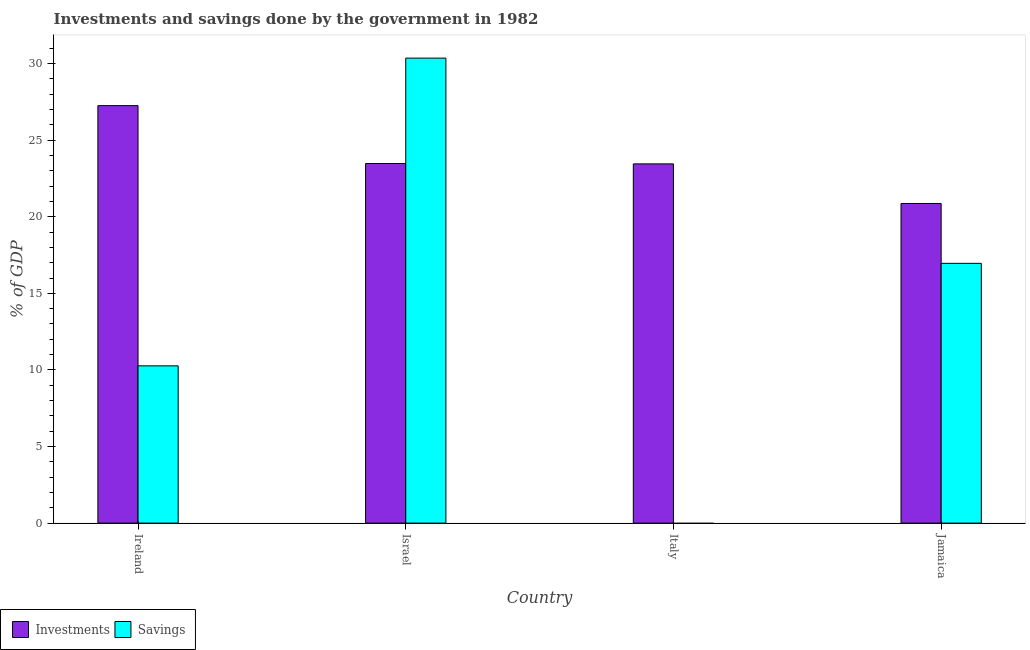How many different coloured bars are there?
Your answer should be very brief. 2. Are the number of bars on each tick of the X-axis equal?
Provide a short and direct response. No. What is the label of the 3rd group of bars from the left?
Ensure brevity in your answer.  Italy. In how many cases, is the number of bars for a given country not equal to the number of legend labels?
Provide a short and direct response. 1. What is the savings of government in Ireland?
Make the answer very short. 10.27. Across all countries, what is the maximum investments of government?
Provide a short and direct response. 27.26. Across all countries, what is the minimum savings of government?
Give a very brief answer. 0. In which country was the savings of government maximum?
Provide a succinct answer. Israel. What is the total investments of government in the graph?
Ensure brevity in your answer.  95.06. What is the difference between the investments of government in Israel and that in Jamaica?
Keep it short and to the point. 2.61. What is the difference between the investments of government in Israel and the savings of government in Ireland?
Make the answer very short. 13.21. What is the average investments of government per country?
Ensure brevity in your answer.  23.76. What is the difference between the investments of government and savings of government in Jamaica?
Ensure brevity in your answer.  3.91. What is the ratio of the investments of government in Ireland to that in Jamaica?
Your answer should be compact. 1.31. Is the savings of government in Ireland less than that in Jamaica?
Ensure brevity in your answer.  Yes. Is the difference between the investments of government in Ireland and Israel greater than the difference between the savings of government in Ireland and Israel?
Your answer should be very brief. Yes. What is the difference between the highest and the second highest investments of government?
Provide a short and direct response. 3.78. What is the difference between the highest and the lowest investments of government?
Keep it short and to the point. 6.39. How many countries are there in the graph?
Your answer should be very brief. 4. What is the difference between two consecutive major ticks on the Y-axis?
Ensure brevity in your answer.  5. Are the values on the major ticks of Y-axis written in scientific E-notation?
Keep it short and to the point. No. Does the graph contain grids?
Offer a very short reply. No. Where does the legend appear in the graph?
Provide a short and direct response. Bottom left. How many legend labels are there?
Provide a succinct answer. 2. What is the title of the graph?
Your answer should be very brief. Investments and savings done by the government in 1982. Does "Unregistered firms" appear as one of the legend labels in the graph?
Offer a very short reply. No. What is the label or title of the Y-axis?
Ensure brevity in your answer.  % of GDP. What is the % of GDP in Investments in Ireland?
Keep it short and to the point. 27.26. What is the % of GDP in Savings in Ireland?
Offer a terse response. 10.27. What is the % of GDP of Investments in Israel?
Your response must be concise. 23.48. What is the % of GDP in Savings in Israel?
Ensure brevity in your answer.  30.36. What is the % of GDP of Investments in Italy?
Your response must be concise. 23.45. What is the % of GDP in Investments in Jamaica?
Keep it short and to the point. 20.87. What is the % of GDP in Savings in Jamaica?
Provide a succinct answer. 16.96. Across all countries, what is the maximum % of GDP in Investments?
Offer a very short reply. 27.26. Across all countries, what is the maximum % of GDP of Savings?
Make the answer very short. 30.36. Across all countries, what is the minimum % of GDP in Investments?
Make the answer very short. 20.87. Across all countries, what is the minimum % of GDP of Savings?
Ensure brevity in your answer.  0. What is the total % of GDP in Investments in the graph?
Your response must be concise. 95.06. What is the total % of GDP of Savings in the graph?
Provide a succinct answer. 57.59. What is the difference between the % of GDP of Investments in Ireland and that in Israel?
Offer a terse response. 3.78. What is the difference between the % of GDP in Savings in Ireland and that in Israel?
Ensure brevity in your answer.  -20.09. What is the difference between the % of GDP in Investments in Ireland and that in Italy?
Provide a short and direct response. 3.8. What is the difference between the % of GDP in Investments in Ireland and that in Jamaica?
Provide a short and direct response. 6.39. What is the difference between the % of GDP in Savings in Ireland and that in Jamaica?
Give a very brief answer. -6.69. What is the difference between the % of GDP in Investments in Israel and that in Italy?
Your answer should be very brief. 0.02. What is the difference between the % of GDP of Investments in Israel and that in Jamaica?
Keep it short and to the point. 2.61. What is the difference between the % of GDP of Savings in Israel and that in Jamaica?
Ensure brevity in your answer.  13.4. What is the difference between the % of GDP of Investments in Italy and that in Jamaica?
Give a very brief answer. 2.59. What is the difference between the % of GDP in Investments in Ireland and the % of GDP in Savings in Israel?
Give a very brief answer. -3.1. What is the difference between the % of GDP of Investments in Ireland and the % of GDP of Savings in Jamaica?
Make the answer very short. 10.3. What is the difference between the % of GDP in Investments in Israel and the % of GDP in Savings in Jamaica?
Provide a short and direct response. 6.52. What is the difference between the % of GDP of Investments in Italy and the % of GDP of Savings in Jamaica?
Provide a succinct answer. 6.5. What is the average % of GDP in Investments per country?
Provide a succinct answer. 23.76. What is the average % of GDP in Savings per country?
Your response must be concise. 14.4. What is the difference between the % of GDP in Investments and % of GDP in Savings in Ireland?
Offer a terse response. 16.99. What is the difference between the % of GDP of Investments and % of GDP of Savings in Israel?
Keep it short and to the point. -6.88. What is the difference between the % of GDP of Investments and % of GDP of Savings in Jamaica?
Make the answer very short. 3.91. What is the ratio of the % of GDP of Investments in Ireland to that in Israel?
Your response must be concise. 1.16. What is the ratio of the % of GDP in Savings in Ireland to that in Israel?
Provide a short and direct response. 0.34. What is the ratio of the % of GDP in Investments in Ireland to that in Italy?
Keep it short and to the point. 1.16. What is the ratio of the % of GDP of Investments in Ireland to that in Jamaica?
Provide a short and direct response. 1.31. What is the ratio of the % of GDP in Savings in Ireland to that in Jamaica?
Your response must be concise. 0.61. What is the ratio of the % of GDP in Investments in Israel to that in Italy?
Provide a short and direct response. 1. What is the ratio of the % of GDP of Savings in Israel to that in Jamaica?
Your answer should be compact. 1.79. What is the ratio of the % of GDP of Investments in Italy to that in Jamaica?
Ensure brevity in your answer.  1.12. What is the difference between the highest and the second highest % of GDP of Investments?
Provide a short and direct response. 3.78. What is the difference between the highest and the second highest % of GDP of Savings?
Your answer should be very brief. 13.4. What is the difference between the highest and the lowest % of GDP in Investments?
Your answer should be compact. 6.39. What is the difference between the highest and the lowest % of GDP in Savings?
Provide a short and direct response. 30.36. 